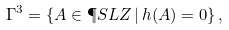<formula> <loc_0><loc_0><loc_500><loc_500>\Gamma ^ { 3 } = \left \{ A \in \P S L Z \, | \, h ( A ) = 0 \right \} ,</formula> 